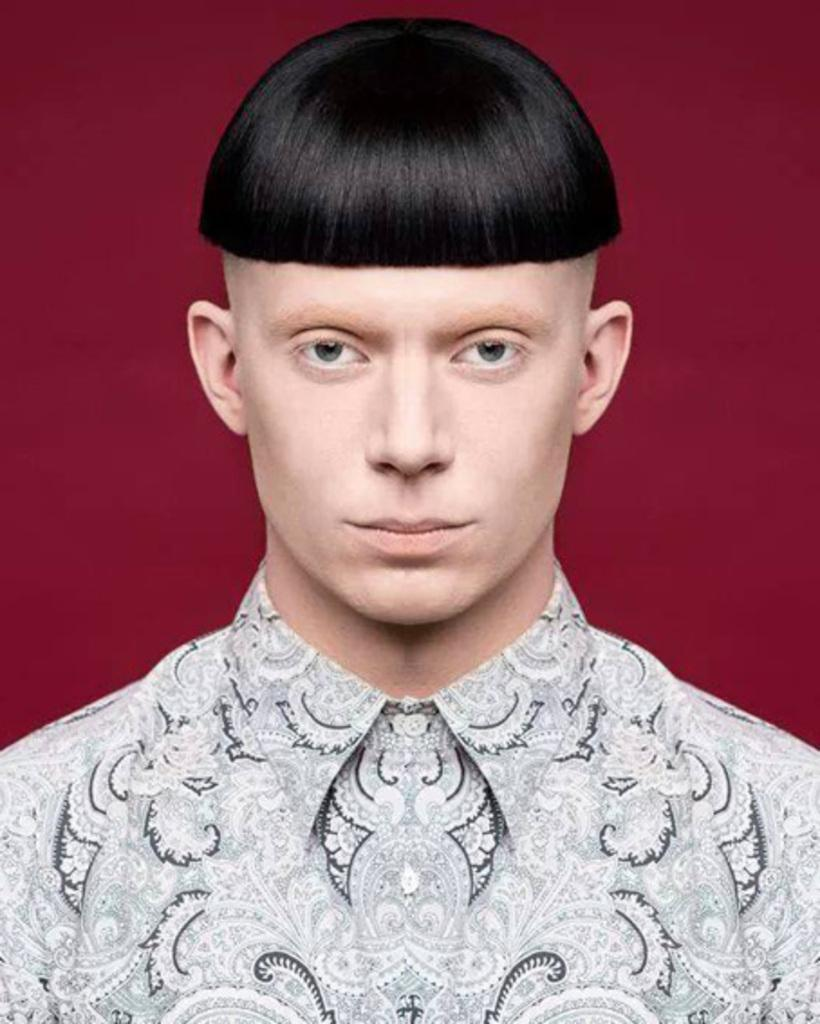Who is present in the image? There is a man in the image. What can be seen in the background of the image? The background of the image is red. What type of clouds can be seen in the image? There are no clouds present in the image; the background is red. 